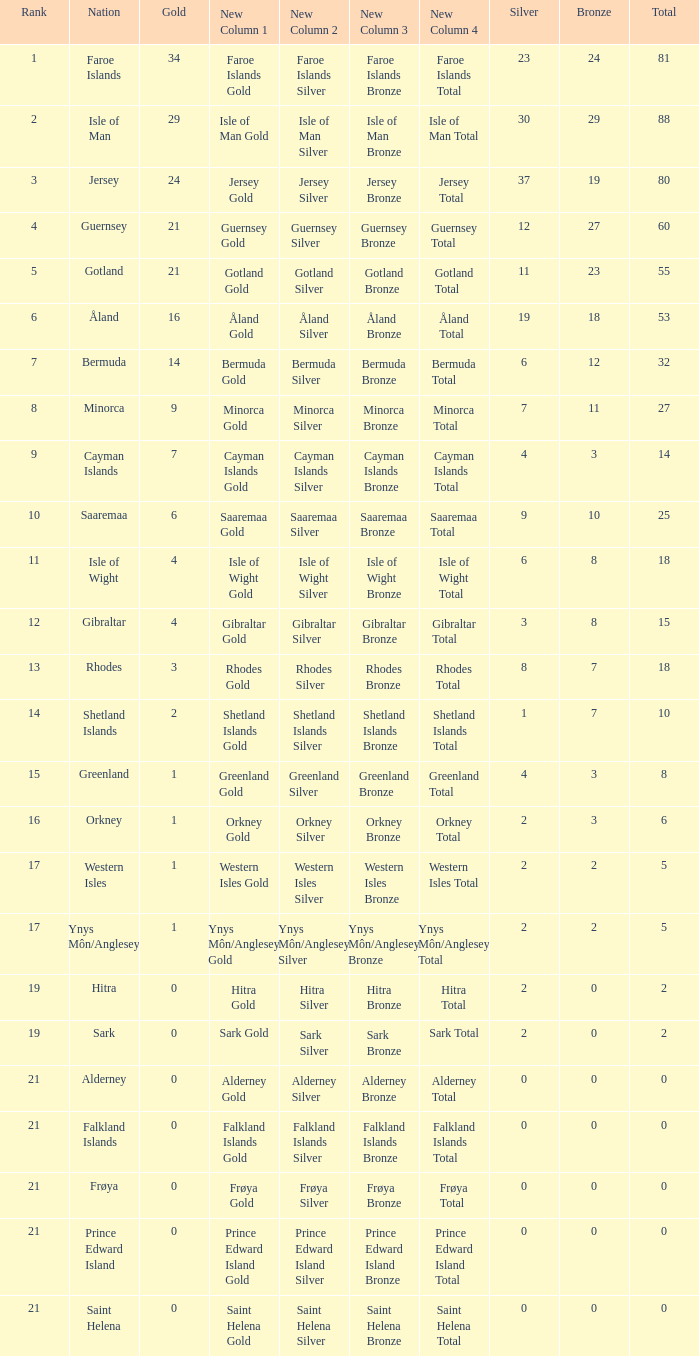How many Silver medals were won in total by all those with more than 3 bronze and exactly 16 gold? 19.0. 